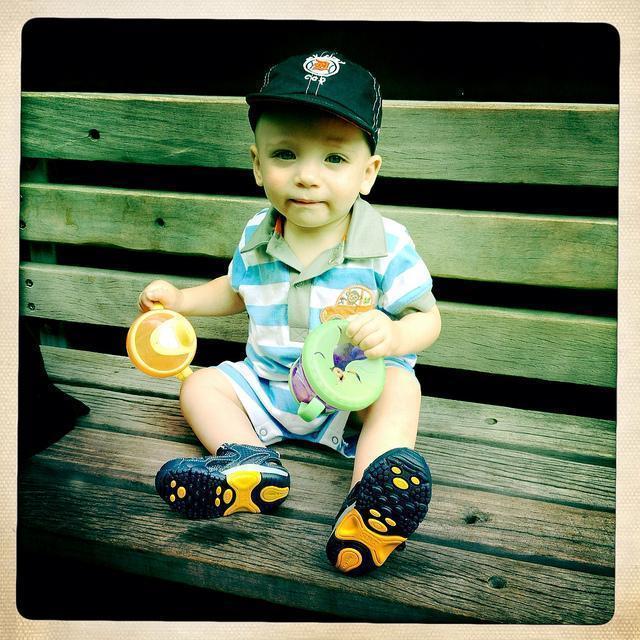What book series does he probably like?
Choose the correct response and explain in the format: 'Answer: answer
Rationale: rationale.'
Options: Berenstain bears, amelia bedelia, clifford, curious george. Answer: curious george.
Rationale: It's a curious george. 